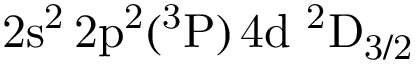Convert formula to latex. <formula><loc_0><loc_0><loc_500><loc_500>2 s ^ { 2 } \, 2 p ^ { 2 } ( ^ { 3 } P ) \, 4 d ^ { 2 } D _ { 3 / 2 }</formula> 